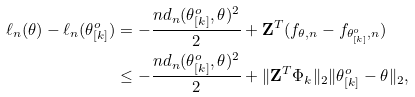Convert formula to latex. <formula><loc_0><loc_0><loc_500><loc_500>\ell _ { n } ( \theta ) - \ell _ { n } ( \theta _ { [ k ] } ^ { o } ) & = - \frac { n d _ { n } ( \theta _ { [ k ] } ^ { o } , \theta ) ^ { 2 } } { 2 } + \mathbf Z ^ { T } ( f _ { \theta , n } - f _ { \theta _ { [ k ] } ^ { o } , n } ) \\ & \leq - \frac { n d _ { n } ( \theta _ { [ k ] } ^ { o } , \theta ) ^ { 2 } } { 2 } + \| \mathbf Z ^ { T } \Phi _ { k } \| _ { 2 } \| \theta _ { [ k ] } ^ { o } - \theta \| _ { 2 } ,</formula> 